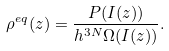<formula> <loc_0><loc_0><loc_500><loc_500>\rho ^ { e q } ( z ) = \frac { P ( I ( z ) ) } { h ^ { 3 N } \Omega ( I ( z ) ) } .</formula> 